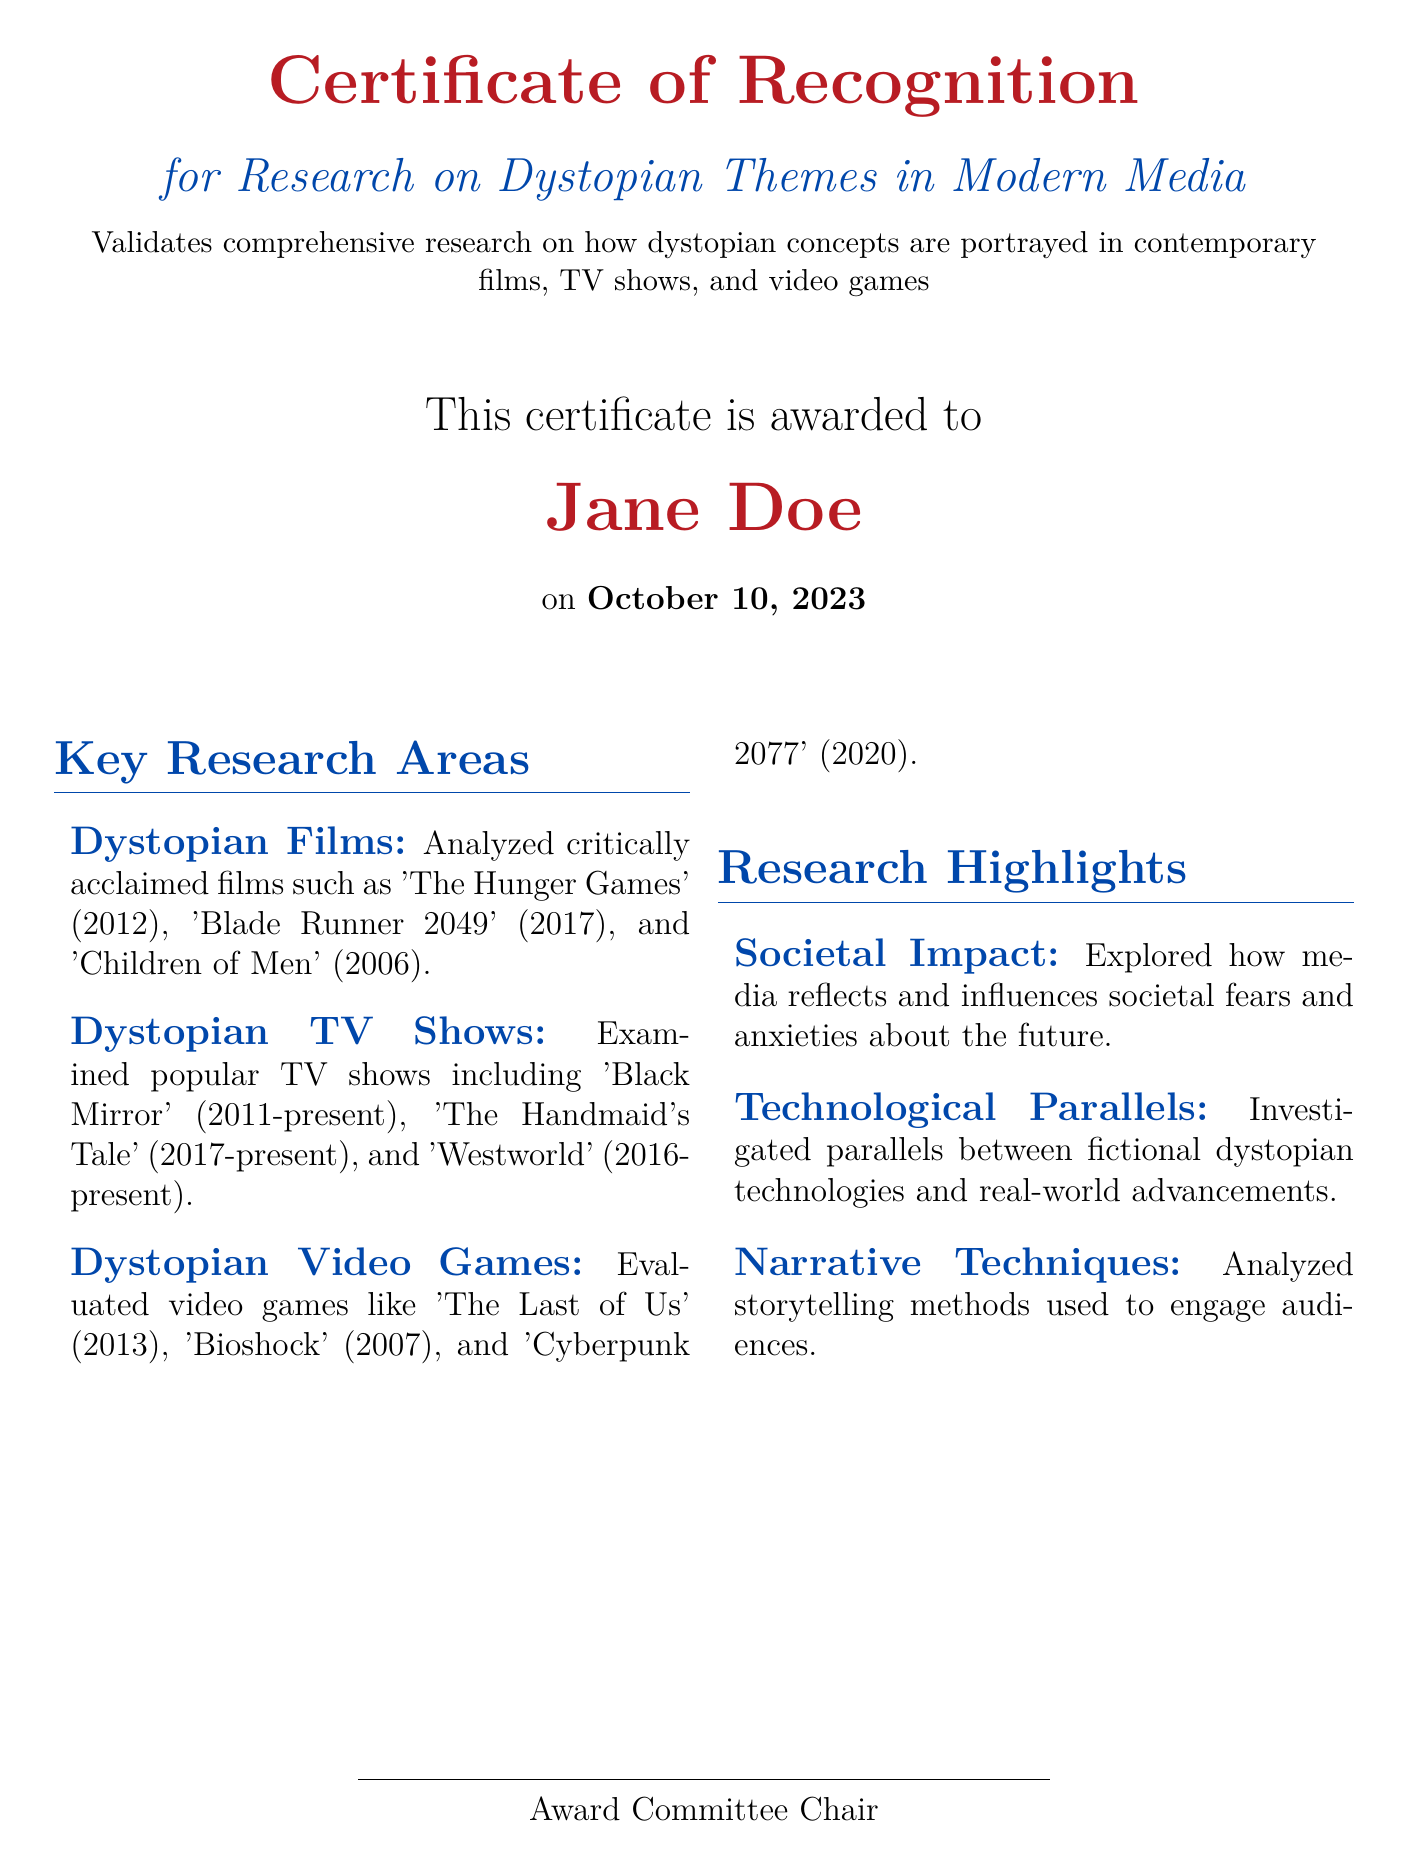What is the title of the certificate? The title clearly states "Certificate of Recognition".
Answer: Certificate of Recognition Who is the certificate awarded to? The document specifies that the award is given to "Jane Doe".
Answer: Jane Doe What is the date of the award? The document states the award date as "October 10, 2023".
Answer: October 10, 2023 What is the first film analyzed in the research? The document lists "The Hunger Games" as the first film under the Dystopian Films section.
Answer: The Hunger Games What is the main research focus of the certificate? The main focus is on "how dystopian concepts are portrayed in contemporary films, TV shows, and video games".
Answer: Dystopian concepts in modern media Which dystopian video game was evaluated in the research? The document mentions "The Last of Us" as one of the evaluated video games.
Answer: The Last of Us What societal aspect was explored in the research highlights? The document indicates that the research explored "how media reflects and influences societal fears and anxieties about the future".
Answer: Societal Impact What color is used for the section titles? The document specifies that the section titles are in "dystopianblue".
Answer: dystopianblue 